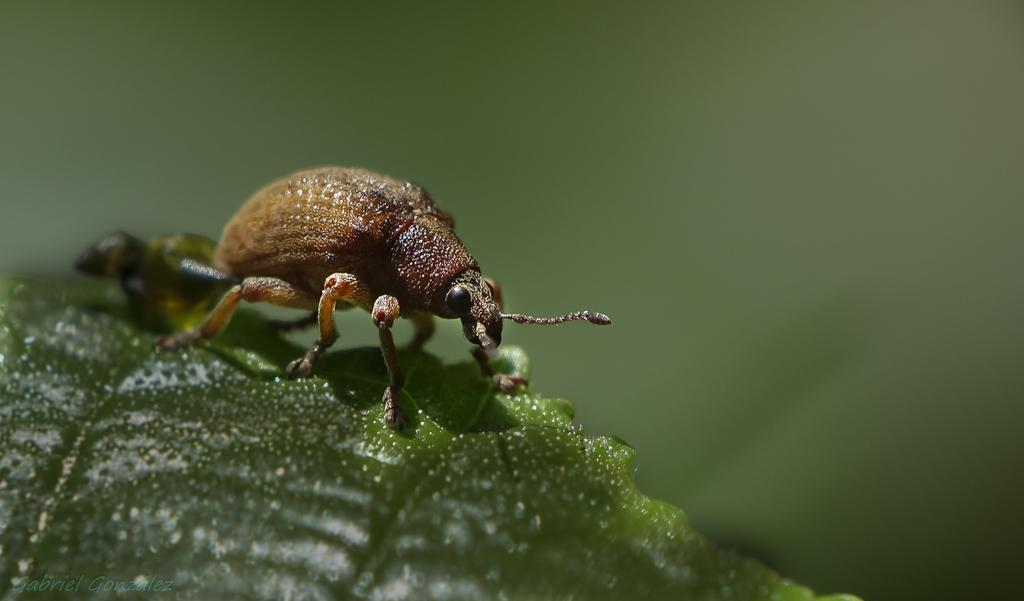What type of creature is present in the image? There is an insect in the image. Where is the insect located? The insect is on a leaf. What type of parcel is the insect holding in the image? There is no parcel present in the image; the insect is simply on a leaf. 